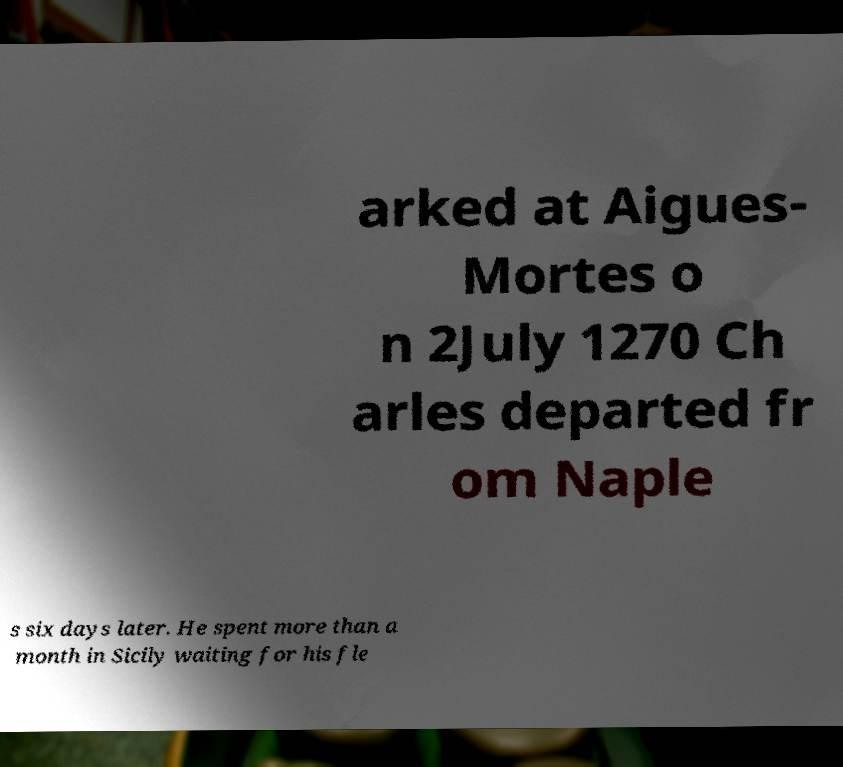There's text embedded in this image that I need extracted. Can you transcribe it verbatim? arked at Aigues- Mortes o n 2July 1270 Ch arles departed fr om Naple s six days later. He spent more than a month in Sicily waiting for his fle 